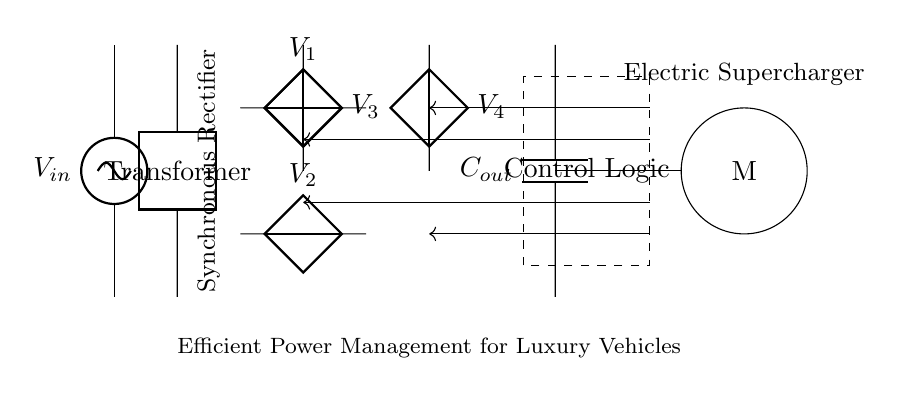What is the input voltage of the circuit? The input voltage is labeled as 'V_in', which indicates it is the source voltage connected to the transformer.
Answer: V_in What is the purpose of the transformer in this circuit? The transformer steps up or steps down the input voltage to a suitable level for the rectification process, ensuring optimal voltage for the synchronous rectifier.
Answer: Voltage adjustment How many capacitors are in the circuit? There is one capacitor labeled 'C_out,' which is responsible for smoothing the output of the rectifier after voltage conversion.
Answer: One What component manages power to the supercharger motor? The control logic manages the gate drivers, which regulate the synchronous rectifier's switching to efficiently deliver power to the supercharger motor.
Answer: Control logic What do the dashed lines represent in the circuit diagram? The dashed lines enclose the control logic section, indicating that it is a separate functional block coordinating the operation of other components in the circuit.
Answer: Control logic How does the synchronous rectifier improve efficiency? The synchronous rectifier employs controlled switching of power devices to minimize losses, allowing for more efficient energy delivery to the supercharger motor, especially under varying load conditions.
Answer: Reduced energy loss 